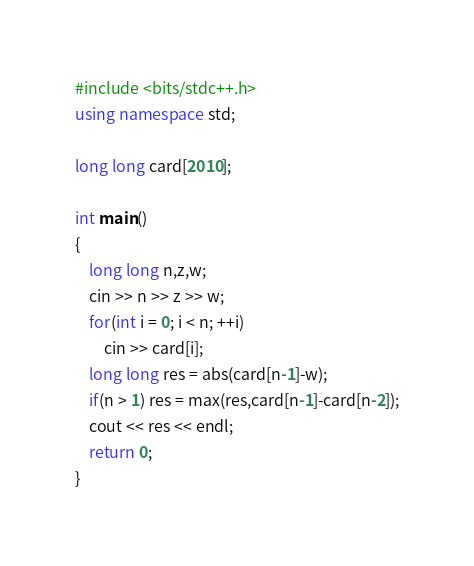<code> <loc_0><loc_0><loc_500><loc_500><_C++_>#include <bits/stdc++.h>
using namespace std;

long long card[2010];

int main()
{
    long long n,z,w;
    cin >> n >> z >> w;
    for(int i = 0; i < n; ++i)
        cin >> card[i];
    long long res = abs(card[n-1]-w);
    if(n > 1) res = max(res,card[n-1]-card[n-2]);
    cout << res << endl;
    return 0;
}
</code> 